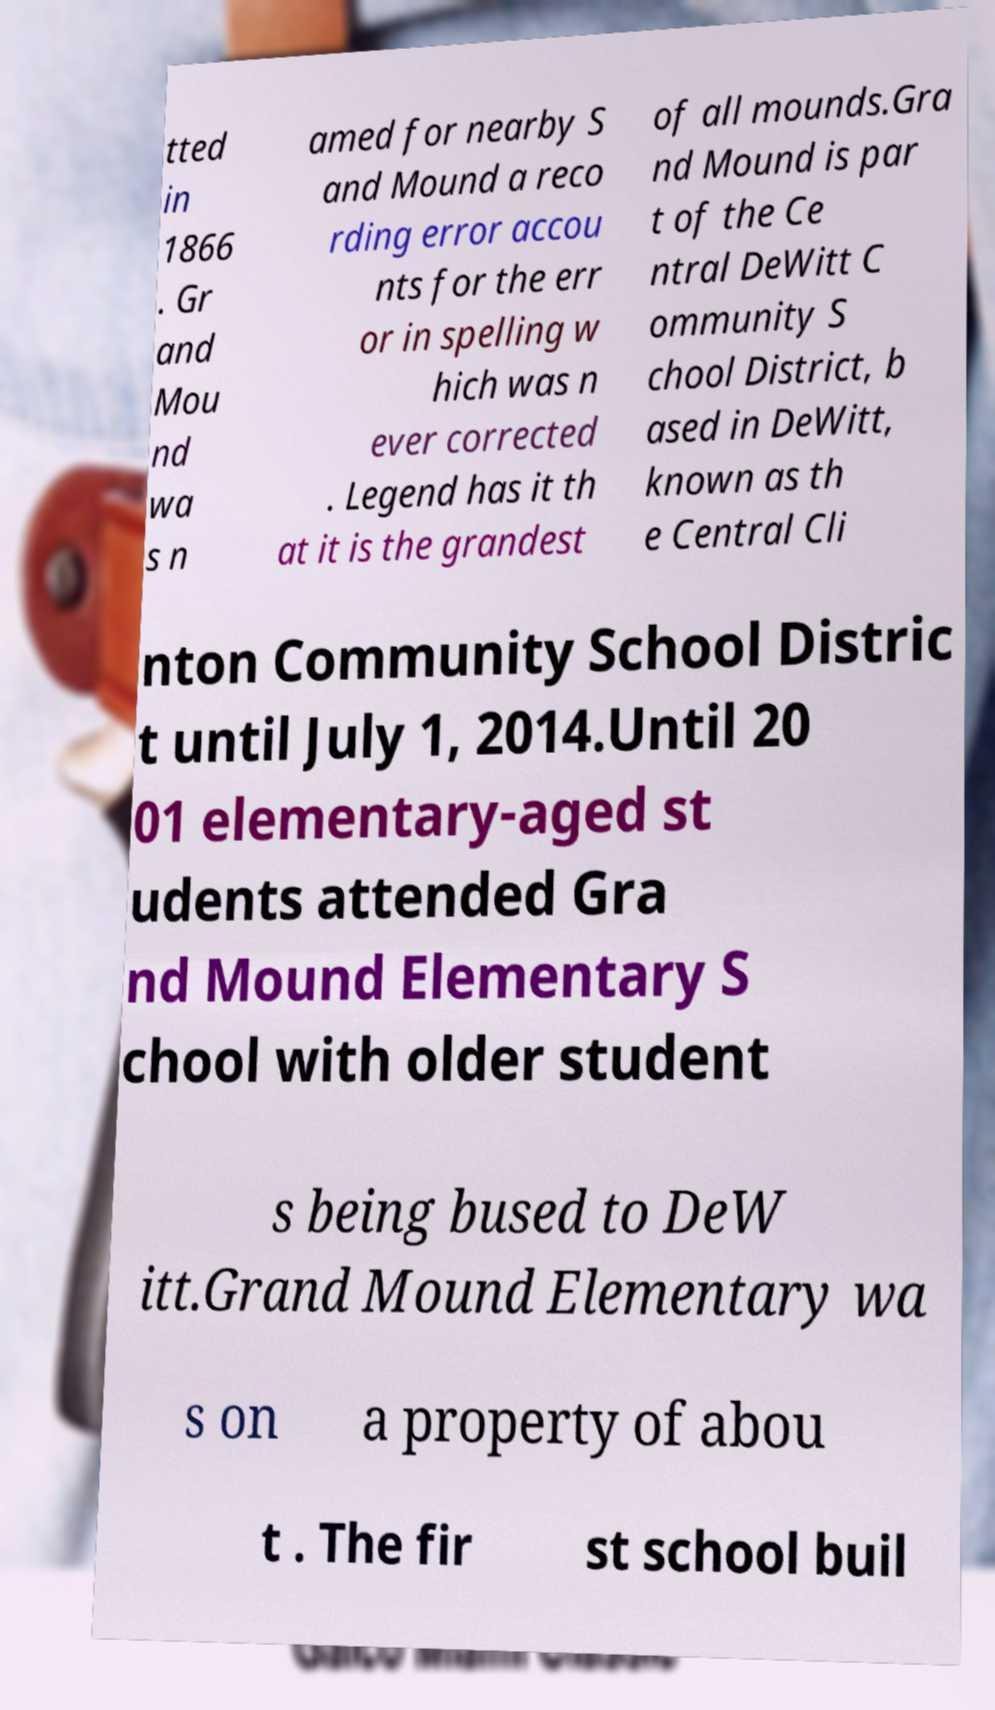Could you assist in decoding the text presented in this image and type it out clearly? tted in 1866 . Gr and Mou nd wa s n amed for nearby S and Mound a reco rding error accou nts for the err or in spelling w hich was n ever corrected . Legend has it th at it is the grandest of all mounds.Gra nd Mound is par t of the Ce ntral DeWitt C ommunity S chool District, b ased in DeWitt, known as th e Central Cli nton Community School Distric t until July 1, 2014.Until 20 01 elementary-aged st udents attended Gra nd Mound Elementary S chool with older student s being bused to DeW itt.Grand Mound Elementary wa s on a property of abou t . The fir st school buil 